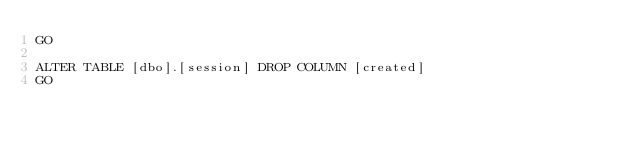<code> <loc_0><loc_0><loc_500><loc_500><_SQL_>GO

ALTER TABLE [dbo].[session] DROP COLUMN [created]
GO
</code> 